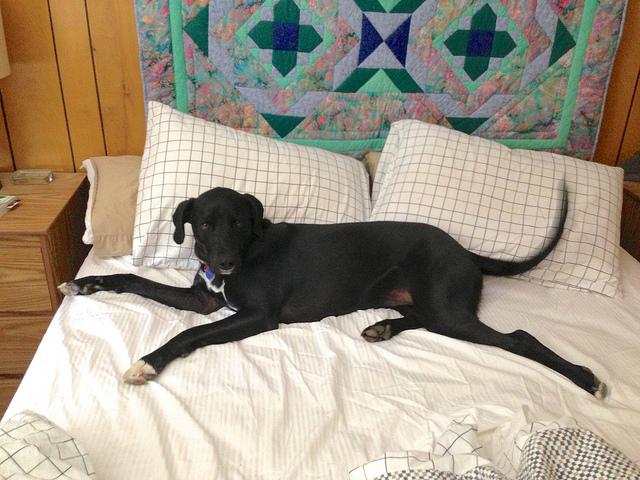What is the dog sitting on?
Quick response, please. Bed. How big is this dog?
Give a very brief answer. Big. Are the dogs asleep?
Concise answer only. No. What color is the sheet?
Keep it brief. White. Is the dog wagging its tail?
Quick response, please. Yes. 